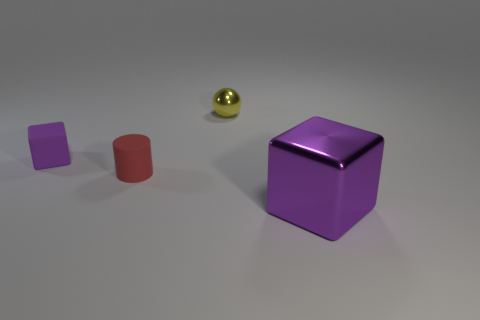Add 2 big brown spheres. How many objects exist? 6 Subtract all cylinders. How many objects are left? 3 Add 3 yellow metal spheres. How many yellow metal spheres exist? 4 Subtract 0 blue blocks. How many objects are left? 4 Subtract all yellow balls. Subtract all small yellow shiny objects. How many objects are left? 2 Add 2 shiny spheres. How many shiny spheres are left? 3 